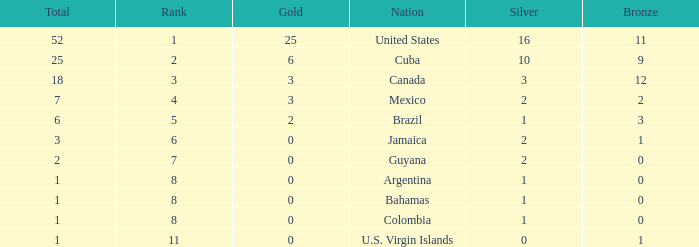What is the fewest number of silver medals a nation who ranked below 8 received? 0.0. 